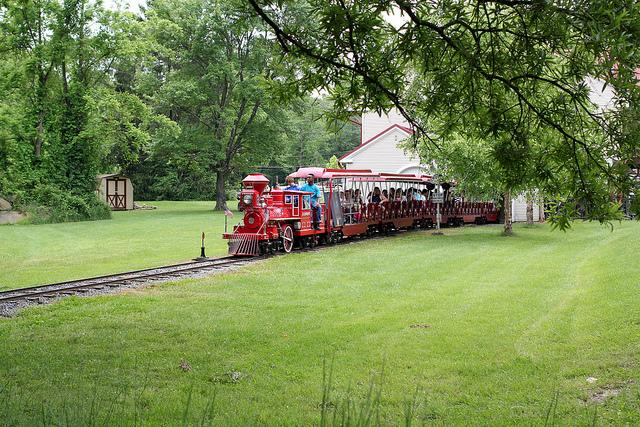What is the small brown structure in the back left of the yard? Please explain your reasoning. shed. The small brown structure in the backyard is a backyard shed. 